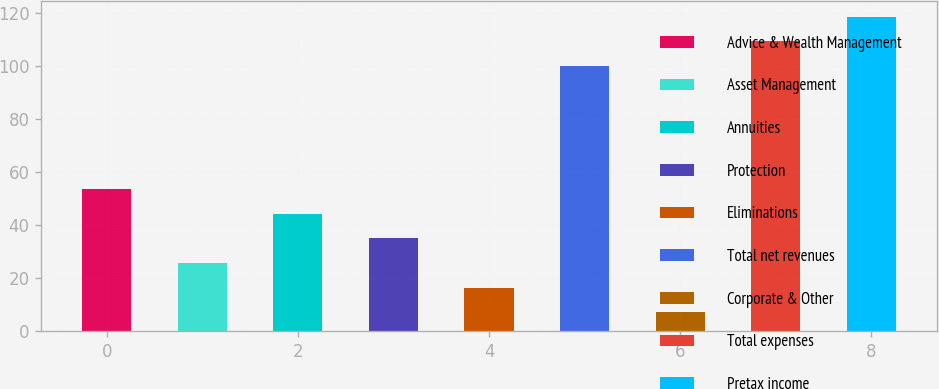Convert chart. <chart><loc_0><loc_0><loc_500><loc_500><bar_chart><fcel>Advice & Wealth Management<fcel>Asset Management<fcel>Annuities<fcel>Protection<fcel>Eliminations<fcel>Total net revenues<fcel>Corporate & Other<fcel>Total expenses<fcel>Pretax income<nl><fcel>53.5<fcel>25.6<fcel>44.2<fcel>34.9<fcel>16.3<fcel>100<fcel>7<fcel>109.3<fcel>118.6<nl></chart> 